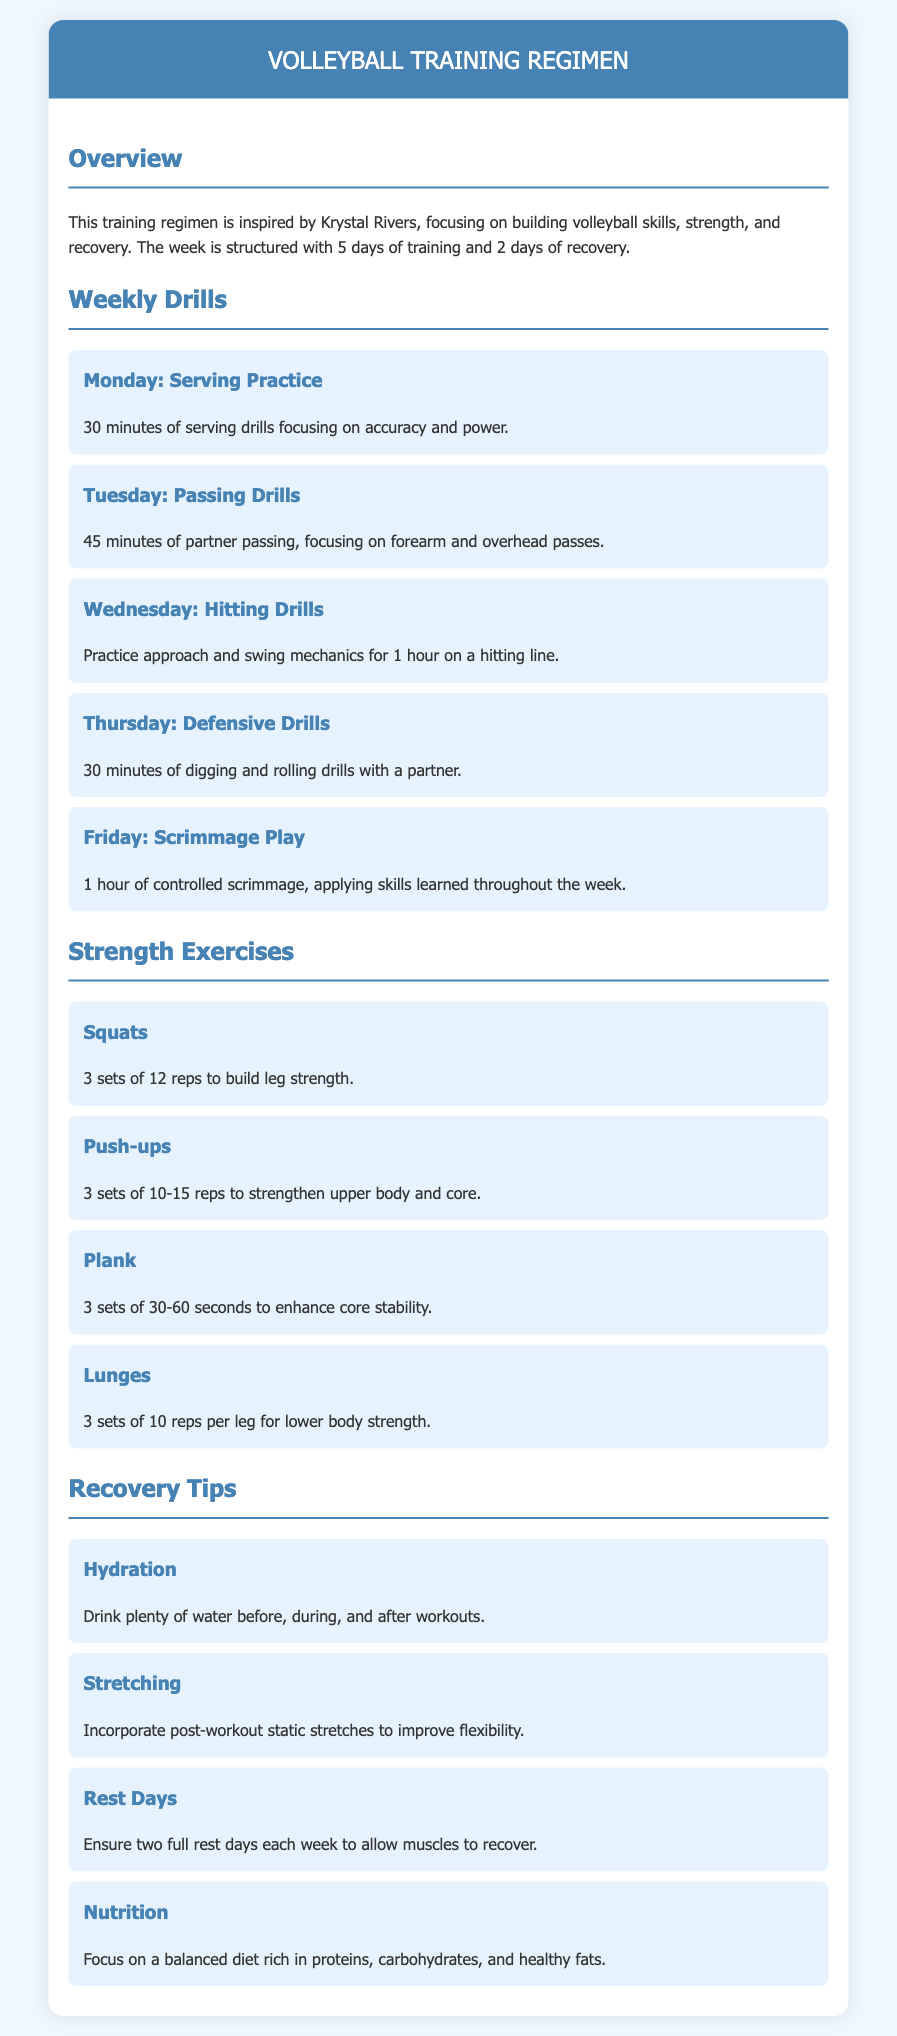What is the focus of the training regimen? The training regimen focuses on building volleyball skills, strength, and recovery, inspired by Krystal Rivers.
Answer: volleyball skills, strength, and recovery How many days are dedicated to training each week? The document states that there are 5 days of training each week.
Answer: 5 days What exercise is performed for core stability? The exercise for core stability mentioned in the document is the Plank.
Answer: Plank How long is the scrimmage play on Friday? According to the document, the scrimmage play on Friday lasts for 1 hour.
Answer: 1 hour What should you drink before, during, and after workouts? The document advises to drink plenty of water before, during, and after workouts.
Answer: water What is the total number of strength exercises listed? There are 4 strength exercises listed in the document.
Answer: 4 What is the purpose of resting two days a week? The reason for resting two days a week is to allow muscles to recover.
Answer: to allow muscles to recover What type of drills are practiced on Wednesday? The drills practiced on Wednesday are Hitting Drills.
Answer: Hitting Drills 